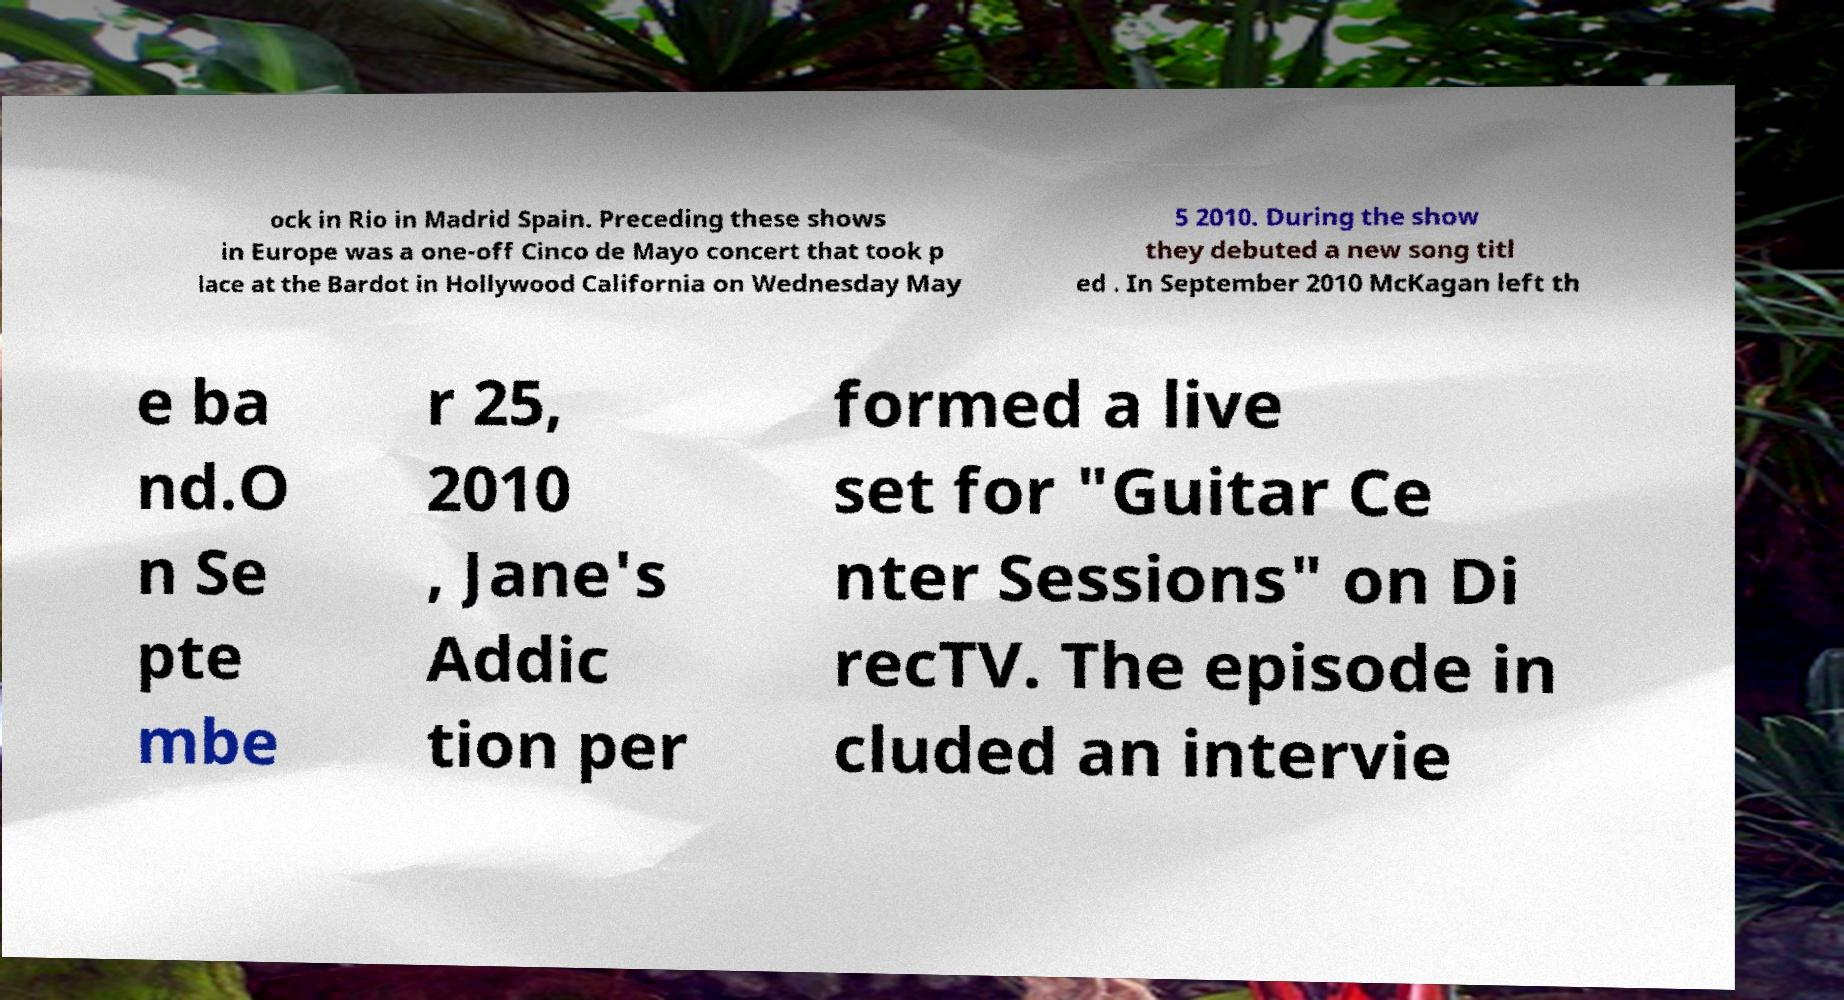Please read and relay the text visible in this image. What does it say? ock in Rio in Madrid Spain. Preceding these shows in Europe was a one-off Cinco de Mayo concert that took p lace at the Bardot in Hollywood California on Wednesday May 5 2010. During the show they debuted a new song titl ed . In September 2010 McKagan left th e ba nd.O n Se pte mbe r 25, 2010 , Jane's Addic tion per formed a live set for "Guitar Ce nter Sessions" on Di recTV. The episode in cluded an intervie 